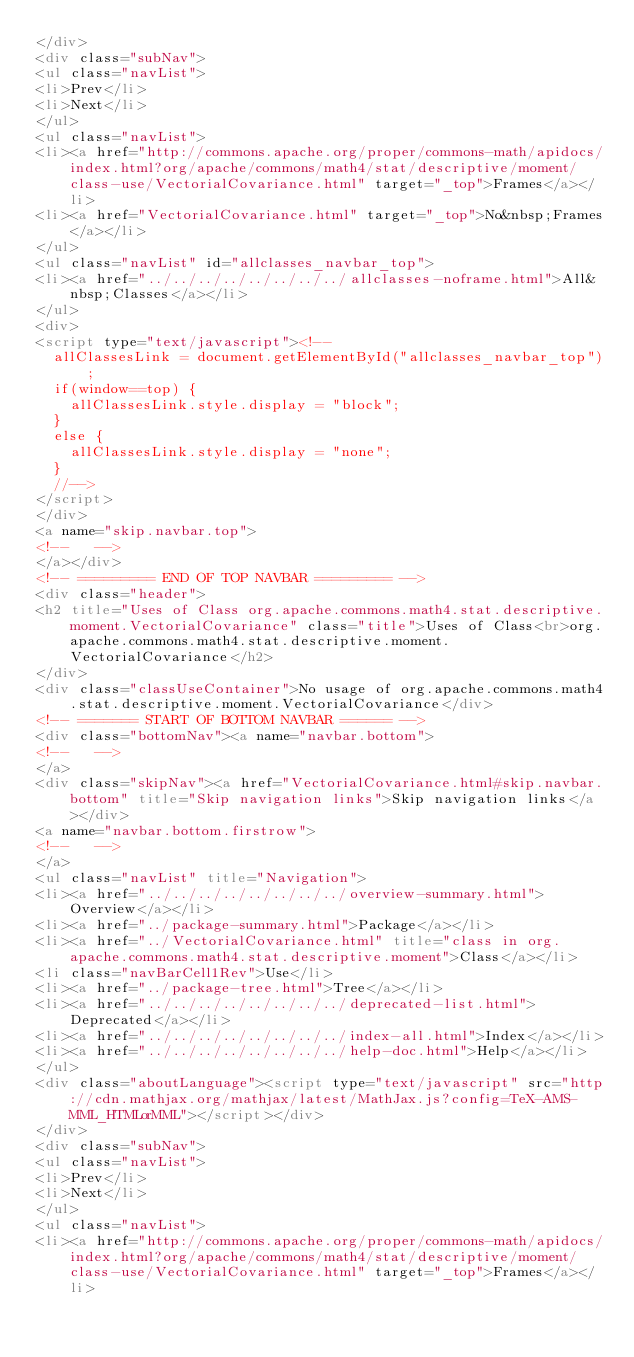<code> <loc_0><loc_0><loc_500><loc_500><_HTML_></div>
<div class="subNav">
<ul class="navList">
<li>Prev</li>
<li>Next</li>
</ul>
<ul class="navList">
<li><a href="http://commons.apache.org/proper/commons-math/apidocs/index.html?org/apache/commons/math4/stat/descriptive/moment/class-use/VectorialCovariance.html" target="_top">Frames</a></li>
<li><a href="VectorialCovariance.html" target="_top">No&nbsp;Frames</a></li>
</ul>
<ul class="navList" id="allclasses_navbar_top">
<li><a href="../../../../../../../../allclasses-noframe.html">All&nbsp;Classes</a></li>
</ul>
<div>
<script type="text/javascript"><!--
  allClassesLink = document.getElementById("allclasses_navbar_top");
  if(window==top) {
    allClassesLink.style.display = "block";
  }
  else {
    allClassesLink.style.display = "none";
  }
  //-->
</script>
</div>
<a name="skip.navbar.top">
<!--   -->
</a></div>
<!-- ========= END OF TOP NAVBAR ========= -->
<div class="header">
<h2 title="Uses of Class org.apache.commons.math4.stat.descriptive.moment.VectorialCovariance" class="title">Uses of Class<br>org.apache.commons.math4.stat.descriptive.moment.VectorialCovariance</h2>
</div>
<div class="classUseContainer">No usage of org.apache.commons.math4.stat.descriptive.moment.VectorialCovariance</div>
<!-- ======= START OF BOTTOM NAVBAR ====== -->
<div class="bottomNav"><a name="navbar.bottom">
<!--   -->
</a>
<div class="skipNav"><a href="VectorialCovariance.html#skip.navbar.bottom" title="Skip navigation links">Skip navigation links</a></div>
<a name="navbar.bottom.firstrow">
<!--   -->
</a>
<ul class="navList" title="Navigation">
<li><a href="../../../../../../../../overview-summary.html">Overview</a></li>
<li><a href="../package-summary.html">Package</a></li>
<li><a href="../VectorialCovariance.html" title="class in org.apache.commons.math4.stat.descriptive.moment">Class</a></li>
<li class="navBarCell1Rev">Use</li>
<li><a href="../package-tree.html">Tree</a></li>
<li><a href="../../../../../../../../deprecated-list.html">Deprecated</a></li>
<li><a href="../../../../../../../../index-all.html">Index</a></li>
<li><a href="../../../../../../../../help-doc.html">Help</a></li>
</ul>
<div class="aboutLanguage"><script type="text/javascript" src="http://cdn.mathjax.org/mathjax/latest/MathJax.js?config=TeX-AMS-MML_HTMLorMML"></script></div>
</div>
<div class="subNav">
<ul class="navList">
<li>Prev</li>
<li>Next</li>
</ul>
<ul class="navList">
<li><a href="http://commons.apache.org/proper/commons-math/apidocs/index.html?org/apache/commons/math4/stat/descriptive/moment/class-use/VectorialCovariance.html" target="_top">Frames</a></li></code> 